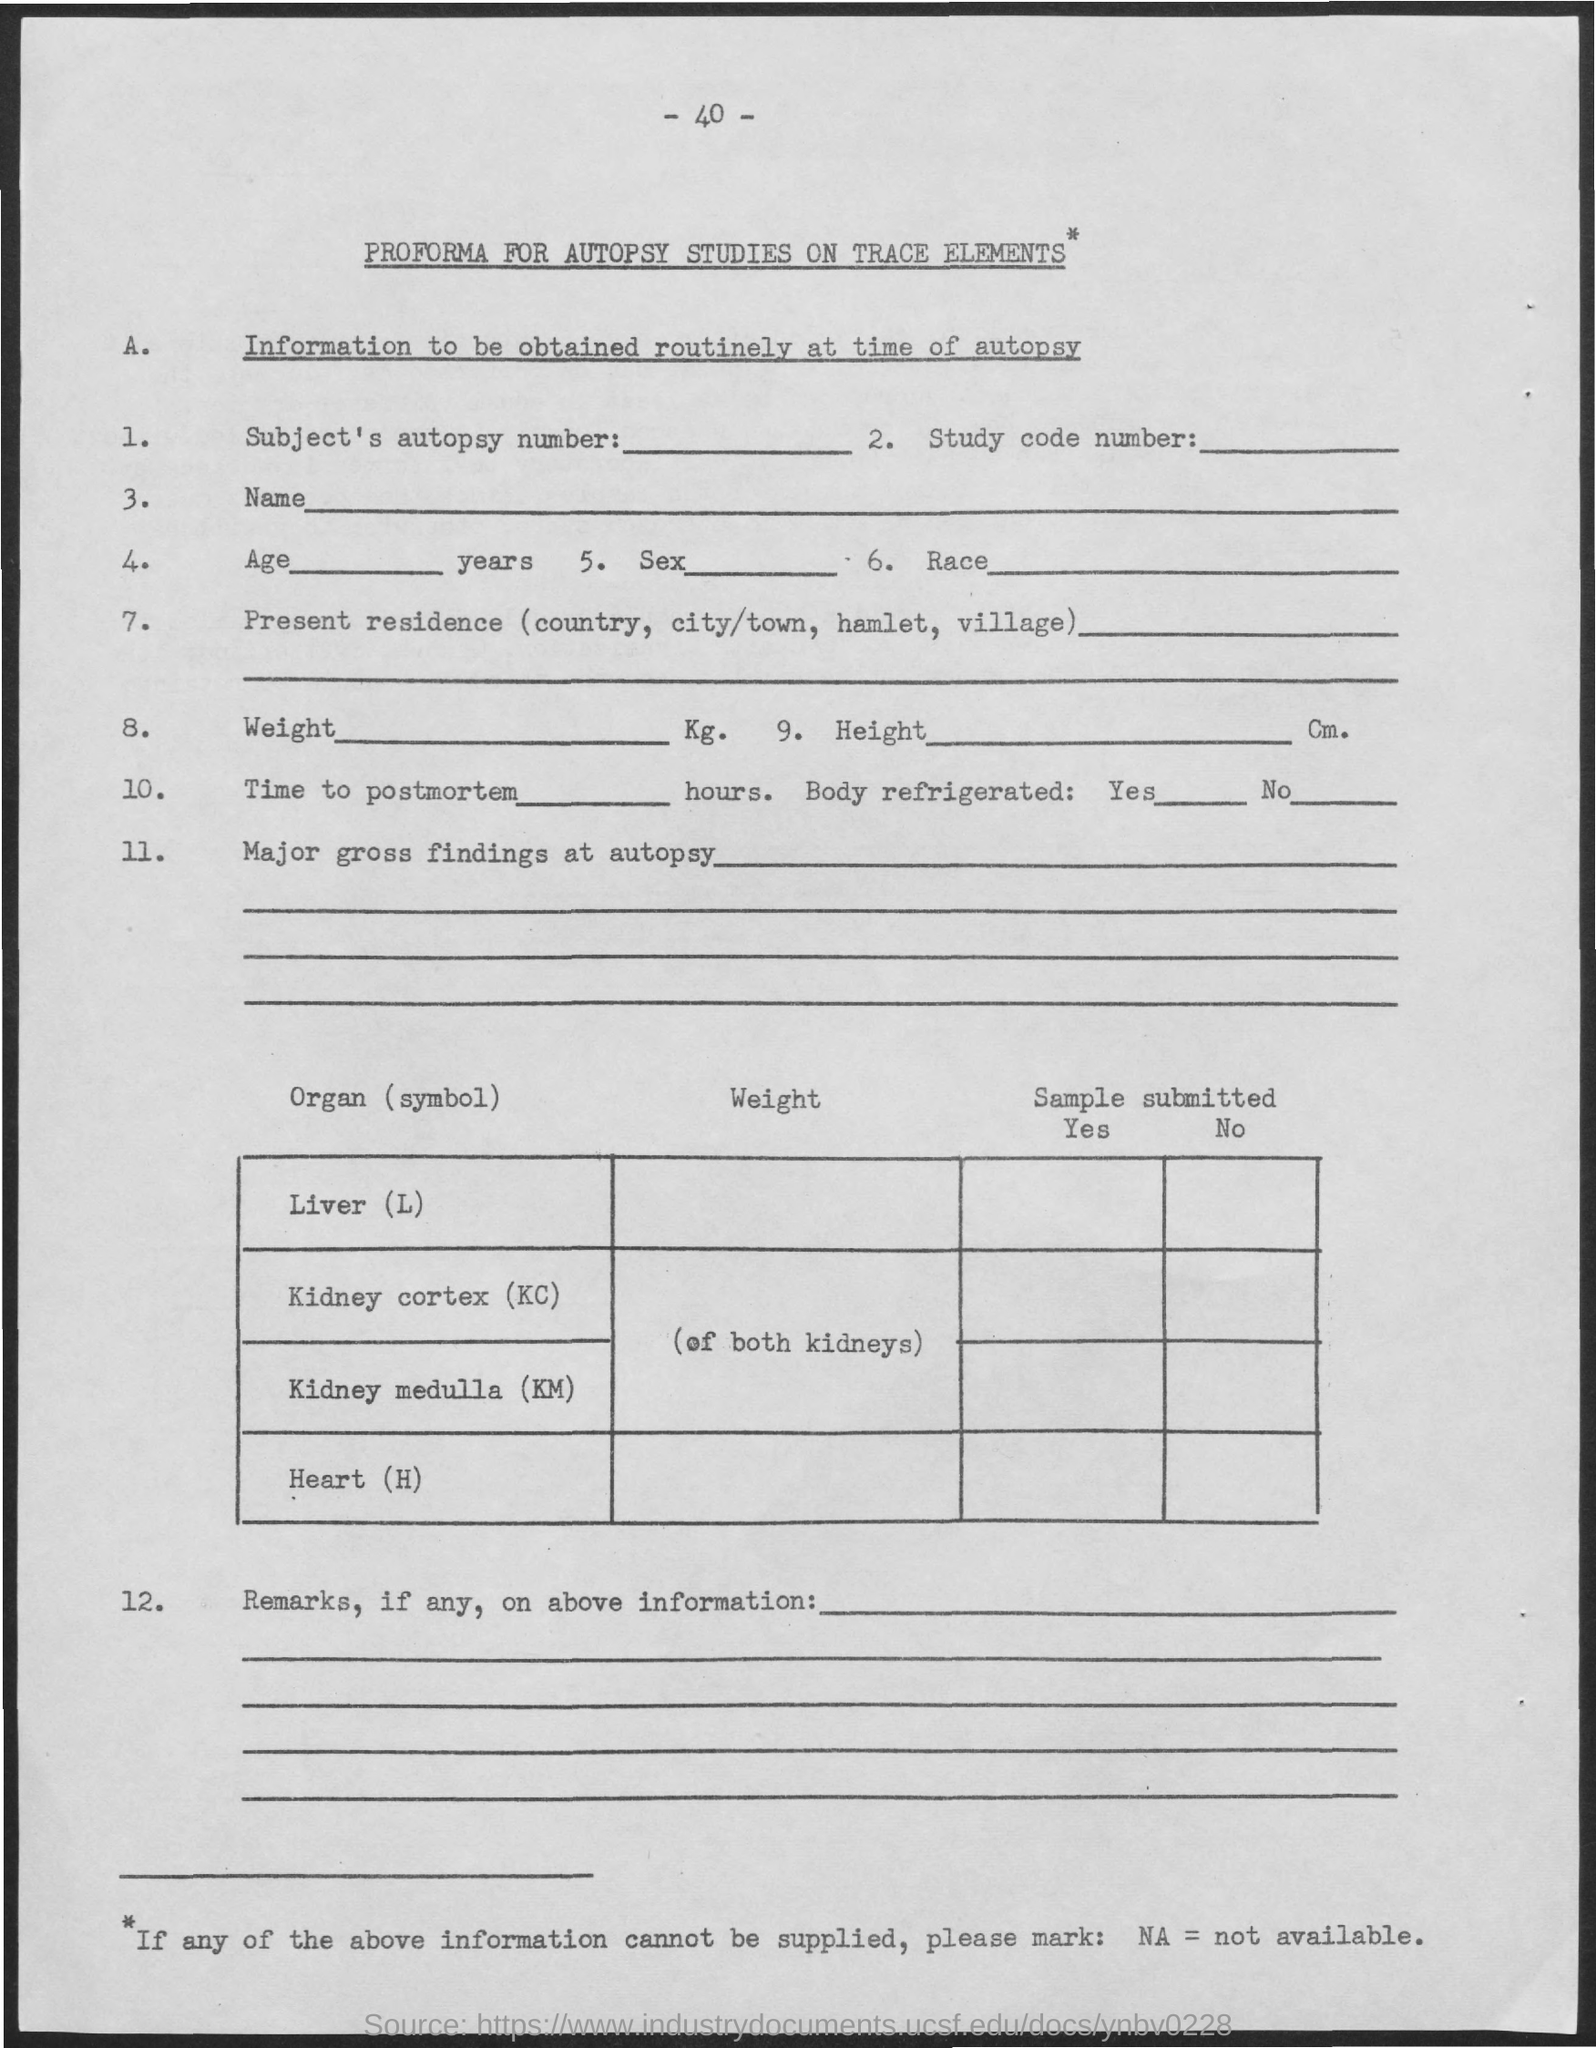Give some essential details in this illustration. What is the full form of NA? I am unable to provide a response at this time. The page number is 40. 